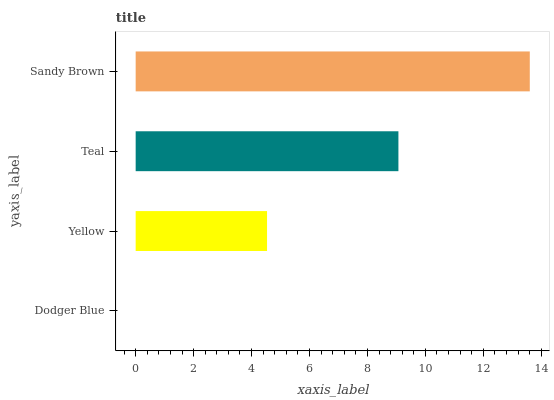Is Dodger Blue the minimum?
Answer yes or no. Yes. Is Sandy Brown the maximum?
Answer yes or no. Yes. Is Yellow the minimum?
Answer yes or no. No. Is Yellow the maximum?
Answer yes or no. No. Is Yellow greater than Dodger Blue?
Answer yes or no. Yes. Is Dodger Blue less than Yellow?
Answer yes or no. Yes. Is Dodger Blue greater than Yellow?
Answer yes or no. No. Is Yellow less than Dodger Blue?
Answer yes or no. No. Is Teal the high median?
Answer yes or no. Yes. Is Yellow the low median?
Answer yes or no. Yes. Is Sandy Brown the high median?
Answer yes or no. No. Is Dodger Blue the low median?
Answer yes or no. No. 